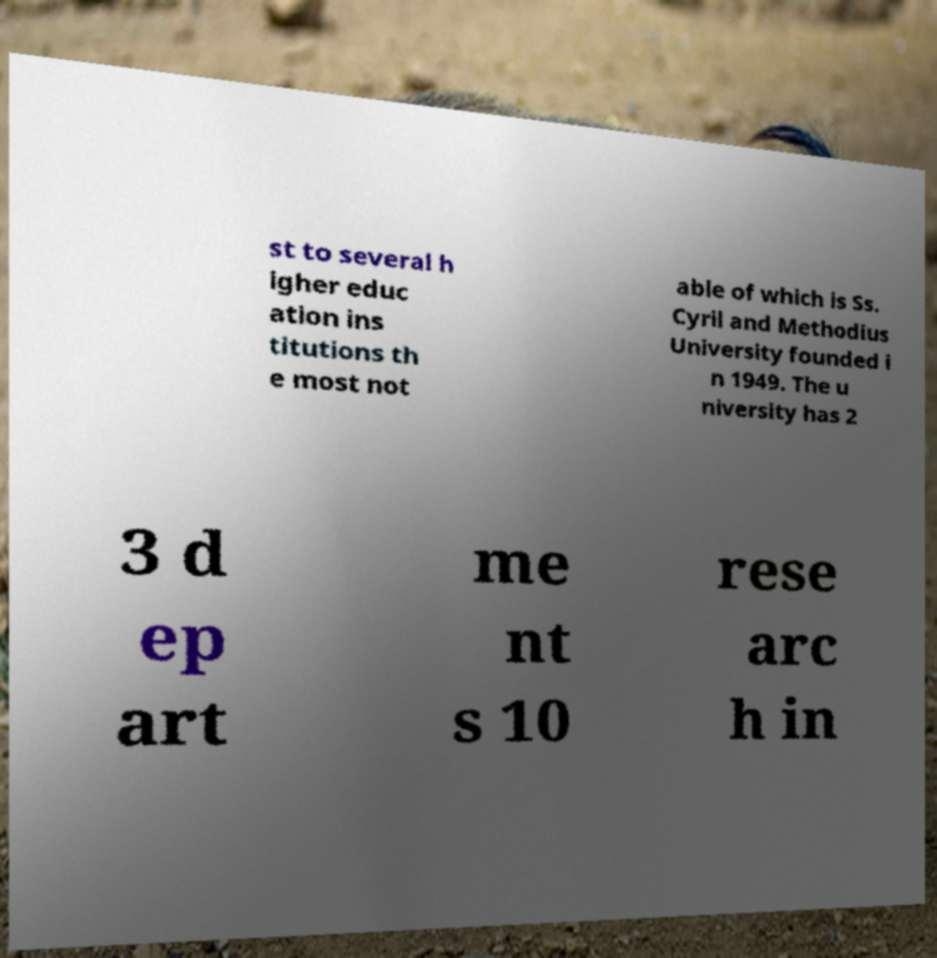Can you read and provide the text displayed in the image?This photo seems to have some interesting text. Can you extract and type it out for me? st to several h igher educ ation ins titutions th e most not able of which is Ss. Cyril and Methodius University founded i n 1949. The u niversity has 2 3 d ep art me nt s 10 rese arc h in 